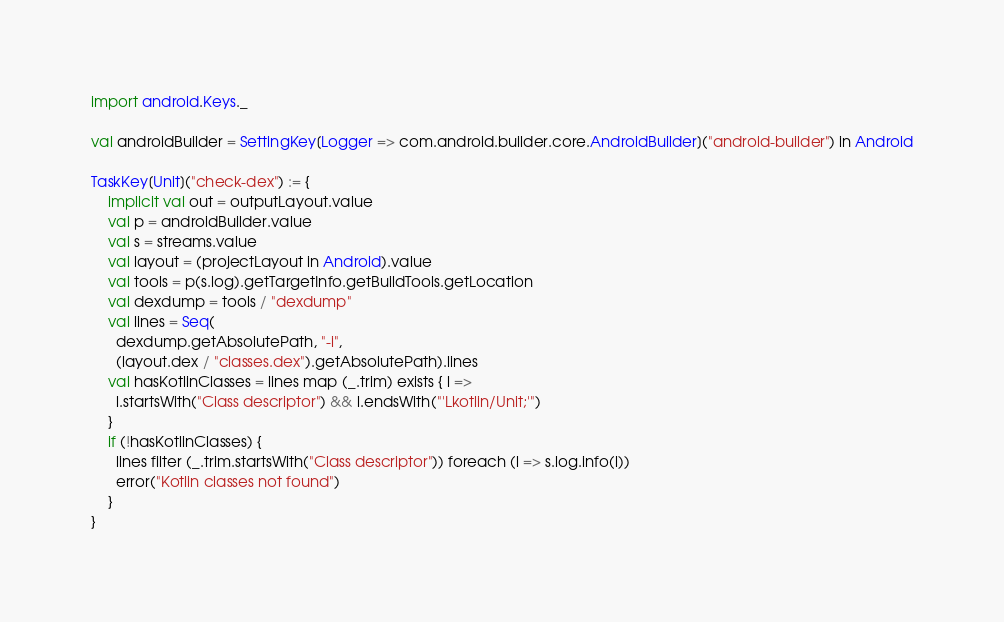<code> <loc_0><loc_0><loc_500><loc_500><_Scala_>import android.Keys._

val androidBuilder = SettingKey[Logger => com.android.builder.core.AndroidBuilder]("android-builder") in Android

TaskKey[Unit]("check-dex") := {
    implicit val out = outputLayout.value
    val p = androidBuilder.value
    val s = streams.value
    val layout = (projectLayout in Android).value
    val tools = p(s.log).getTargetInfo.getBuildTools.getLocation
    val dexdump = tools / "dexdump"
    val lines = Seq(
      dexdump.getAbsolutePath, "-i",
      (layout.dex / "classes.dex").getAbsolutePath).lines
    val hasKotlinClasses = lines map (_.trim) exists { l =>
      l.startsWith("Class descriptor") && l.endsWith("'Lkotlin/Unit;'")
    }
    if (!hasKotlinClasses) {
      lines filter (_.trim.startsWith("Class descriptor")) foreach (l => s.log.info(l))
      error("Kotlin classes not found")
    }
}</code> 